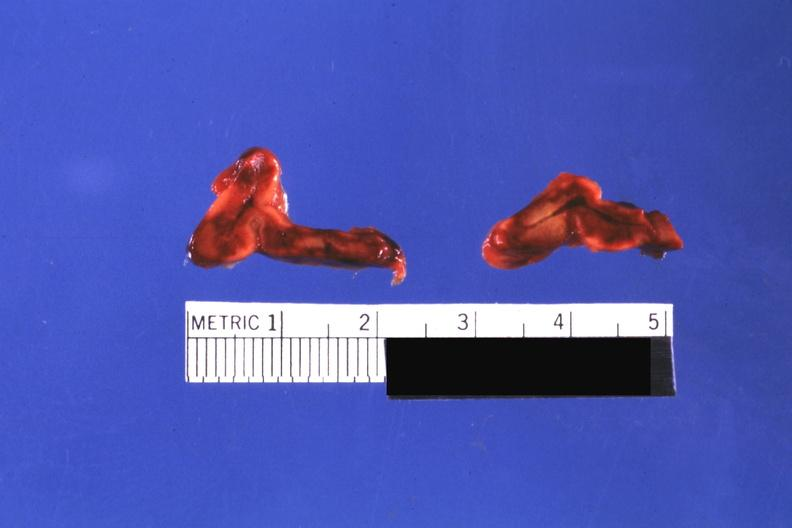what does this image show?
Answer the question using a single word or phrase. Cut surfaces of both adrenals focal hemorrhagic infarction well shown do not know history looks like placental abruption 